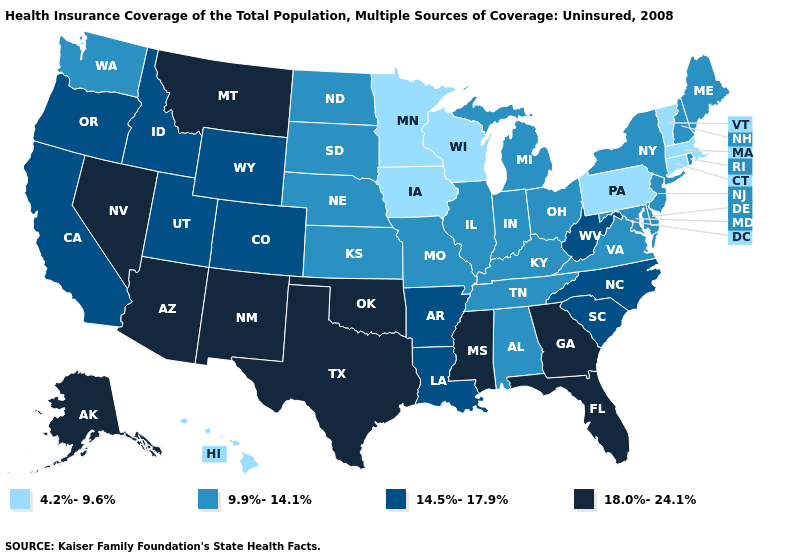What is the value of Kentucky?
Give a very brief answer. 9.9%-14.1%. Name the states that have a value in the range 4.2%-9.6%?
Answer briefly. Connecticut, Hawaii, Iowa, Massachusetts, Minnesota, Pennsylvania, Vermont, Wisconsin. Name the states that have a value in the range 9.9%-14.1%?
Short answer required. Alabama, Delaware, Illinois, Indiana, Kansas, Kentucky, Maine, Maryland, Michigan, Missouri, Nebraska, New Hampshire, New Jersey, New York, North Dakota, Ohio, Rhode Island, South Dakota, Tennessee, Virginia, Washington. Does Massachusetts have the lowest value in the USA?
Be succinct. Yes. Name the states that have a value in the range 18.0%-24.1%?
Answer briefly. Alaska, Arizona, Florida, Georgia, Mississippi, Montana, Nevada, New Mexico, Oklahoma, Texas. Does Nevada have the same value as Kansas?
Give a very brief answer. No. Name the states that have a value in the range 14.5%-17.9%?
Keep it brief. Arkansas, California, Colorado, Idaho, Louisiana, North Carolina, Oregon, South Carolina, Utah, West Virginia, Wyoming. How many symbols are there in the legend?
Keep it brief. 4. What is the value of Maryland?
Keep it brief. 9.9%-14.1%. What is the highest value in the MidWest ?
Concise answer only. 9.9%-14.1%. Does California have the same value as Iowa?
Quick response, please. No. Does Connecticut have the lowest value in the USA?
Write a very short answer. Yes. Name the states that have a value in the range 14.5%-17.9%?
Keep it brief. Arkansas, California, Colorado, Idaho, Louisiana, North Carolina, Oregon, South Carolina, Utah, West Virginia, Wyoming. Name the states that have a value in the range 4.2%-9.6%?
Concise answer only. Connecticut, Hawaii, Iowa, Massachusetts, Minnesota, Pennsylvania, Vermont, Wisconsin. Does Florida have the highest value in the USA?
Answer briefly. Yes. 